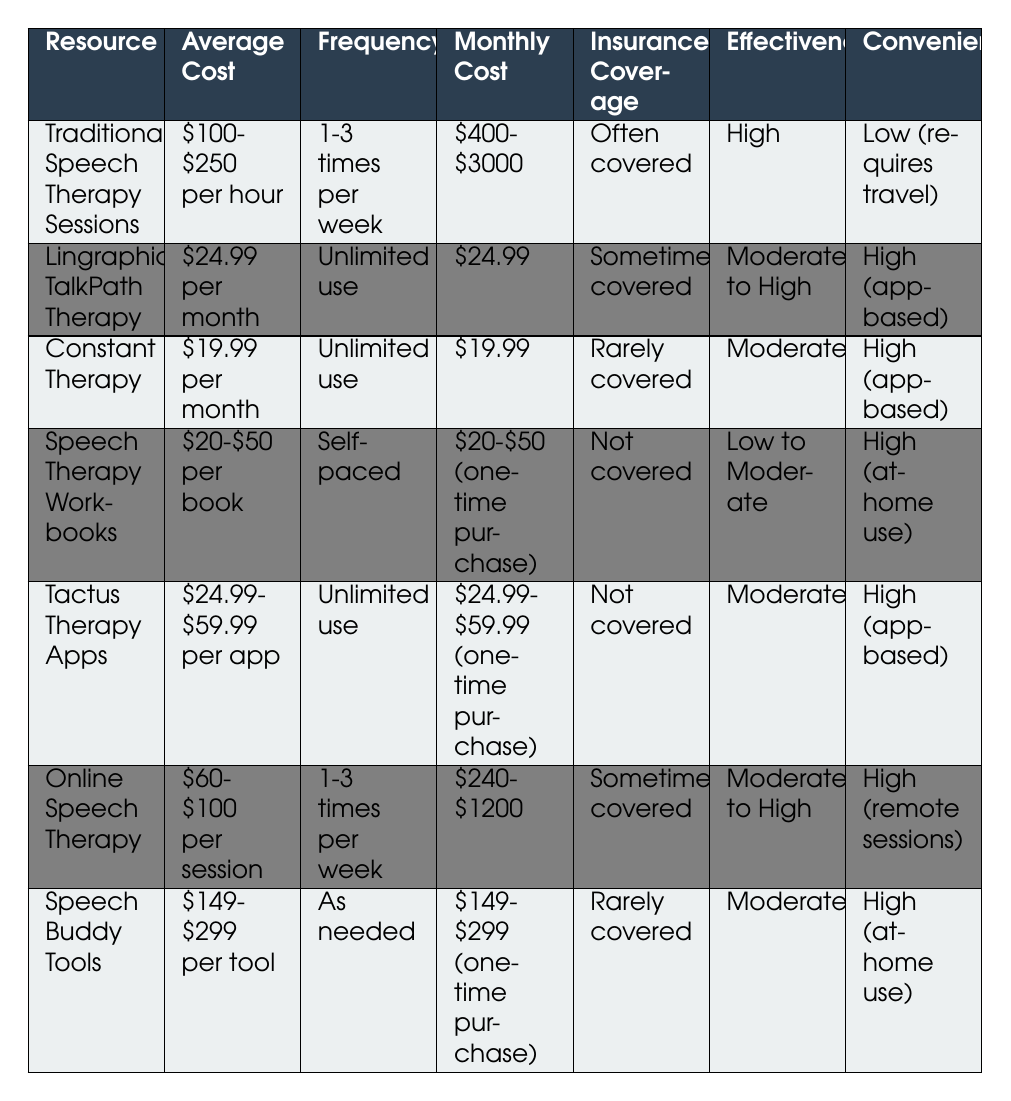What is the average cost of Traditional Speech Therapy Sessions per hour? The table states that the average cost of Traditional Speech Therapy Sessions is "$100-$250 per hour." Therefore, the answer is simply to reference that information.
Answer: $100-$250 per hour How much will you pay monthly for Lingraphica TalkPath Therapy? The table shows that the monthly cost for Lingraphica TalkPath Therapy is "$24.99." Therefore, that is the amount you would have to pay every month for this service.
Answer: $24.99 Is insurance coverage often provided for Speech Therapy Workbooks? The table indicates that the insurance coverage for Speech Therapy Workbooks is "Not covered." Thus, the answer to the question is straightforwardly derived from that specific row.
Answer: No What is the range of monthly costs for Online Speech Therapy? The table provides that the monthly cost for Online Speech Therapy ranges from "$240 to $1200." To find the answer, you can directly extract the range from the corresponding row.
Answer: $240-$1200 Which resource has the highest monthly cost range? Comparing the monthly costs listed in the table, Traditional Speech Therapy Sessions has a range of "$400-$3000," which is greater than any other monthly cost. Thus, you can determine that this resource has the highest range by looking for the maximum value noted in the relevant column.
Answer: Traditional Speech Therapy Sessions If you combine the average costs of Tactus Therapy Apps, what's the minimum and maximum range? Tactus Therapy Apps has an average cost range of "$24.99-$59.99." Thus, by interpreting this value as a combination of minimum ($24.99) and maximum ($59.99), you can find that these are the corresponding limits. So, in total lowest and highest based on this entry will be $24.99 and $59.99 respectively.
Answer: $24.99-$59.99 Which type of resource provides high convenience and moderate effectiveness? By reviewing the table, you can see that both Constant Therapy and Tactus Therapy Apps are noted to have "High" convenience along with "Moderate" effectiveness. Therefore, you can summarize these two resources as the correct answer.
Answer: Constant Therapy, Tactus Therapy Apps Is there a resource that has unlimited use for a lower cost than $25 per month? The table specifies that Constant Therapy offers a cost of "$19.99 per month," which is less than $25 and has "Unlimited use." Hence, by examining the cost and quantity of usage, you can confirm that this resource meets the criteria.
Answer: Yes What is the total cost for using Traditional Speech Therapy Sessions for three sessions a week over a month? If each session costs an average of $100 to $250, considering three sessions per week, the monthly cost would be between $1,200 (3 sessions x 4 weeks x $100) and $3,000 (3 sessions x 4 weeks x $250). Therefore, this gives the total cost range based on the frequency and the price points provided.
Answer: $1200-$3000 